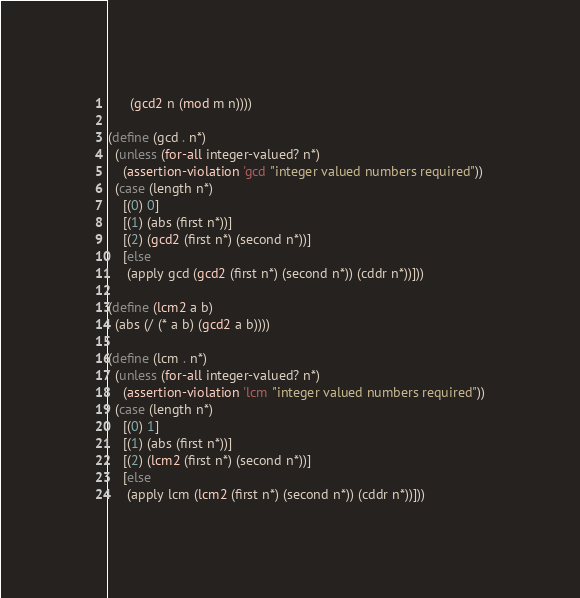<code> <loc_0><loc_0><loc_500><loc_500><_Scheme_>      (gcd2 n (mod m n))))

(define (gcd . n*)
  (unless (for-all integer-valued? n*)
    (assertion-violation 'gcd "integer valued numbers required"))
  (case (length n*)
    [(0) 0]
    [(1) (abs (first n*))]
    [(2) (gcd2 (first n*) (second n*))]
    [else
     (apply gcd (gcd2 (first n*) (second n*)) (cddr n*))]))

(define (lcm2 a b)
  (abs (/ (* a b) (gcd2 a b))))

(define (lcm . n*)
  (unless (for-all integer-valued? n*)
    (assertion-violation 'lcm "integer valued numbers required"))
  (case (length n*)
    [(0) 1]
    [(1) (abs (first n*))]
    [(2) (lcm2 (first n*) (second n*))]
    [else
     (apply lcm (lcm2 (first n*) (second n*)) (cddr n*))]))
</code> 